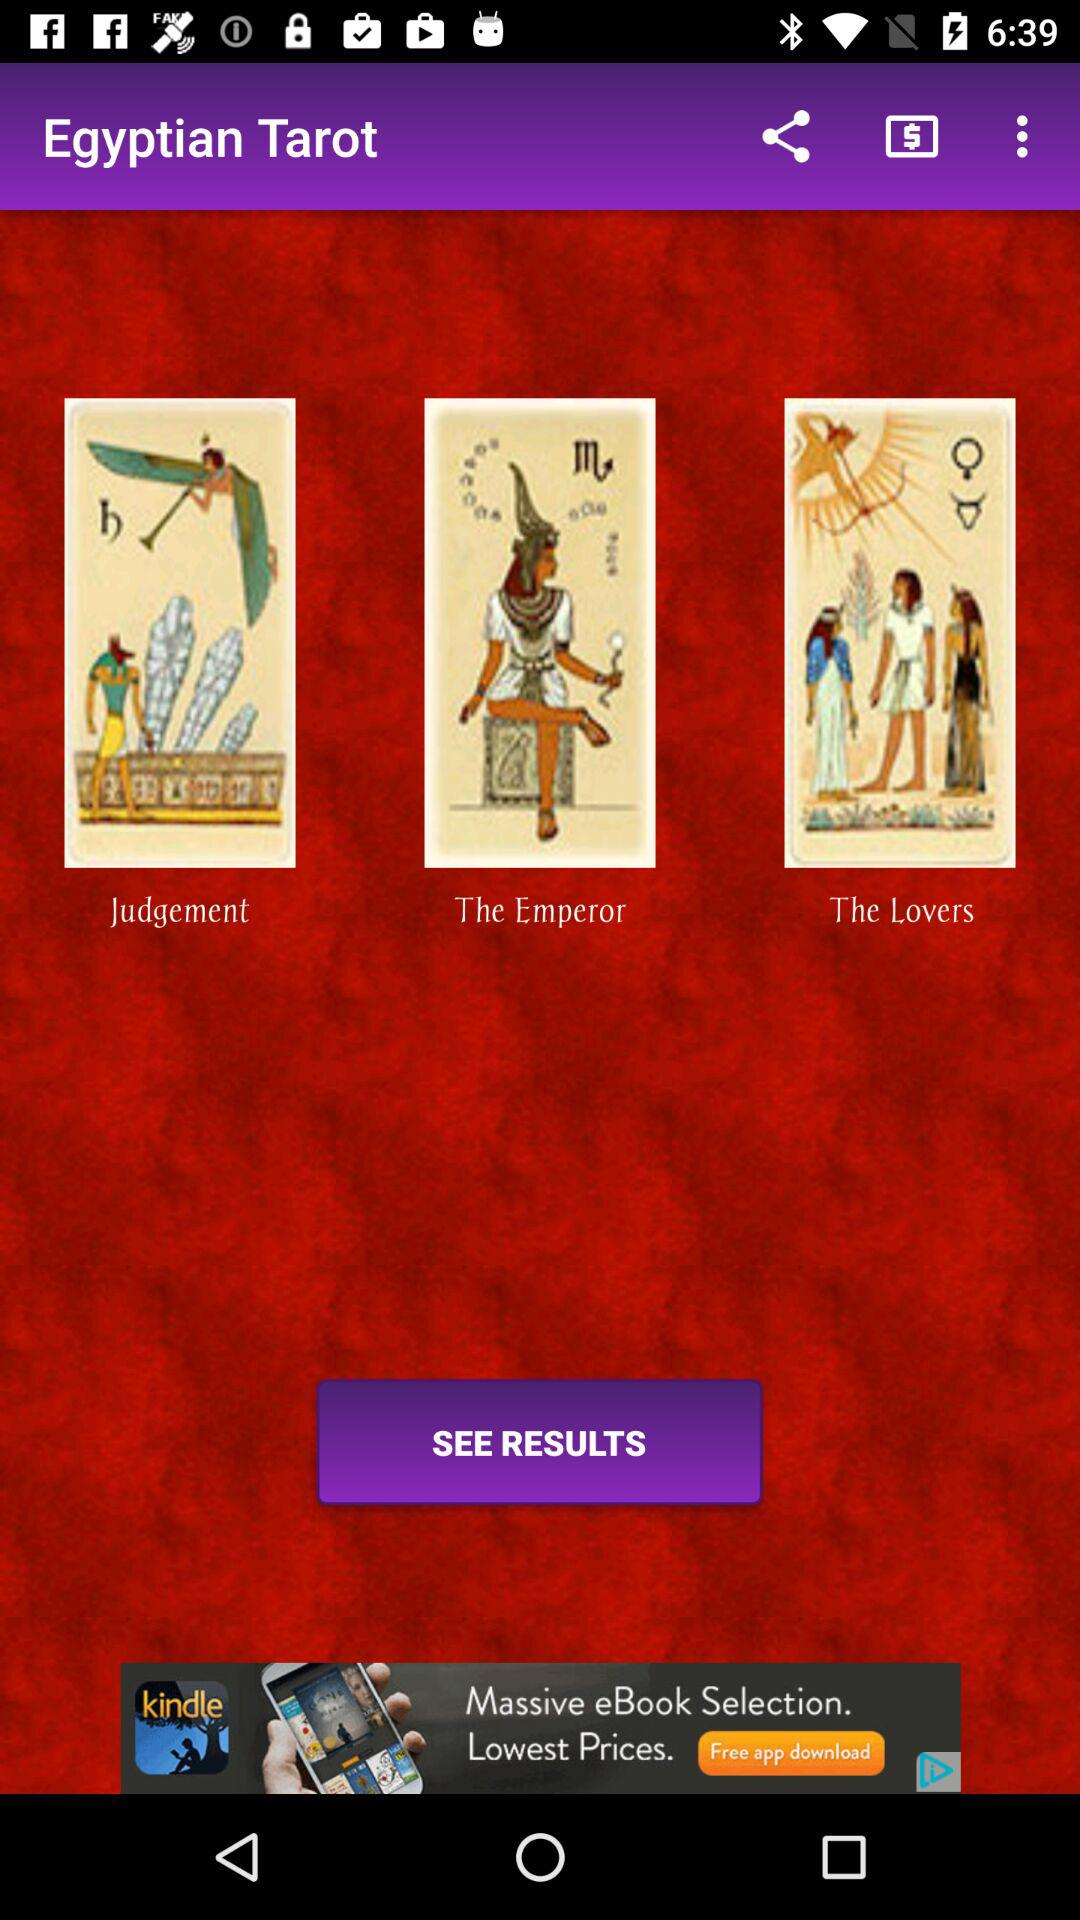What is the name of the application? The name of the application is "Egyptian Tarot". 